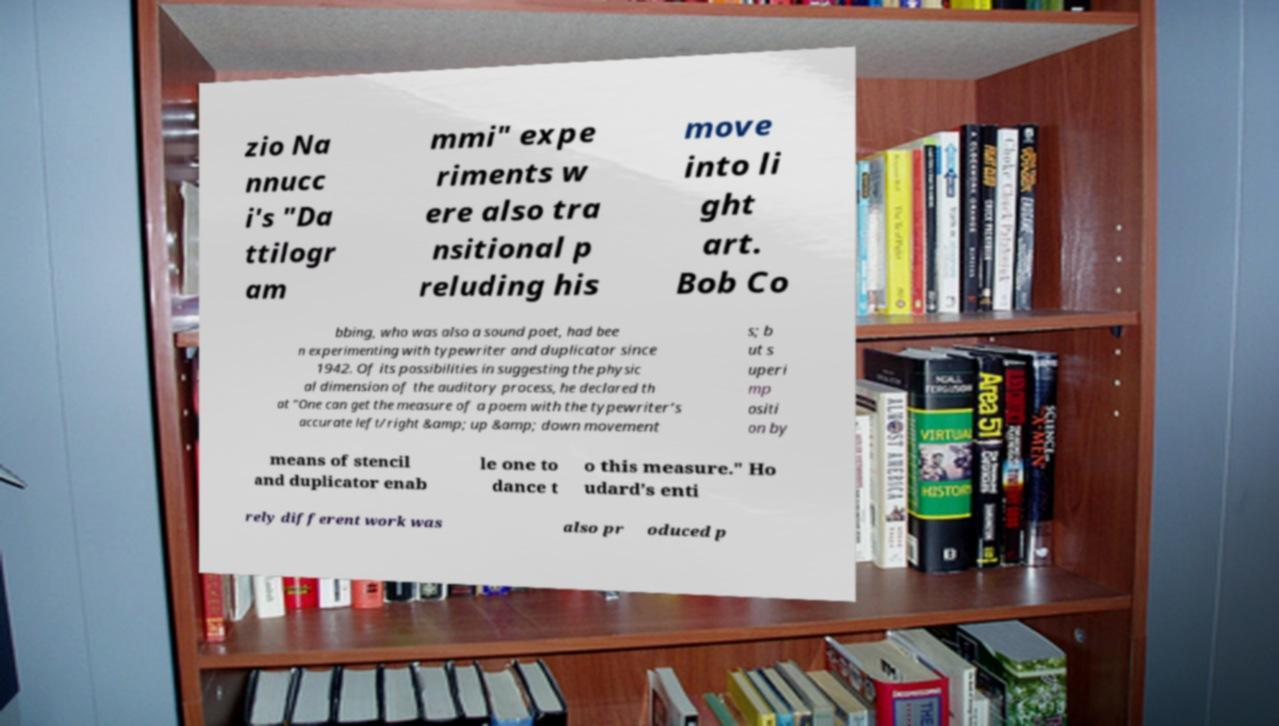Can you accurately transcribe the text from the provided image for me? zio Na nnucc i's "Da ttilogr am mmi" expe riments w ere also tra nsitional p reluding his move into li ght art. Bob Co bbing, who was also a sound poet, had bee n experimenting with typewriter and duplicator since 1942. Of its possibilities in suggesting the physic al dimension of the auditory process, he declared th at "One can get the measure of a poem with the typewriter’s accurate left/right &amp; up &amp; down movement s; b ut s uperi mp ositi on by means of stencil and duplicator enab le one to dance t o this measure." Ho udard’s enti rely different work was also pr oduced p 